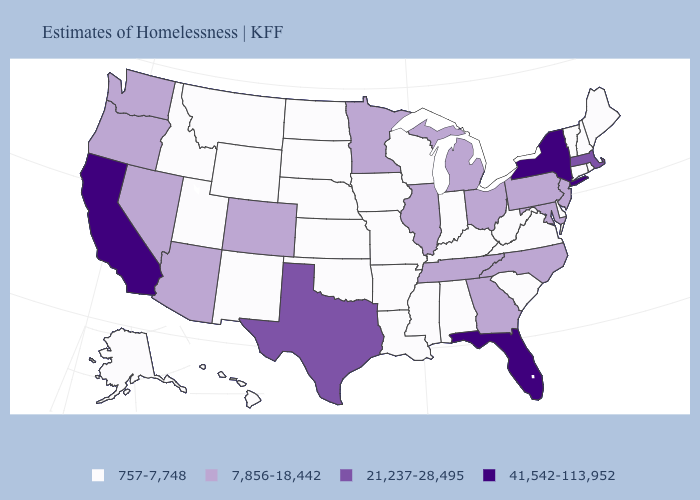Name the states that have a value in the range 7,856-18,442?
Keep it brief. Arizona, Colorado, Georgia, Illinois, Maryland, Michigan, Minnesota, Nevada, New Jersey, North Carolina, Ohio, Oregon, Pennsylvania, Tennessee, Washington. Among the states that border North Dakota , which have the highest value?
Write a very short answer. Minnesota. Name the states that have a value in the range 41,542-113,952?
Keep it brief. California, Florida, New York. Name the states that have a value in the range 757-7,748?
Be succinct. Alabama, Alaska, Arkansas, Connecticut, Delaware, Hawaii, Idaho, Indiana, Iowa, Kansas, Kentucky, Louisiana, Maine, Mississippi, Missouri, Montana, Nebraska, New Hampshire, New Mexico, North Dakota, Oklahoma, Rhode Island, South Carolina, South Dakota, Utah, Vermont, Virginia, West Virginia, Wisconsin, Wyoming. Name the states that have a value in the range 757-7,748?
Be succinct. Alabama, Alaska, Arkansas, Connecticut, Delaware, Hawaii, Idaho, Indiana, Iowa, Kansas, Kentucky, Louisiana, Maine, Mississippi, Missouri, Montana, Nebraska, New Hampshire, New Mexico, North Dakota, Oklahoma, Rhode Island, South Carolina, South Dakota, Utah, Vermont, Virginia, West Virginia, Wisconsin, Wyoming. Does the map have missing data?
Quick response, please. No. What is the lowest value in the South?
Be succinct. 757-7,748. Does New Jersey have the lowest value in the USA?
Keep it brief. No. Does Michigan have the lowest value in the USA?
Concise answer only. No. Among the states that border Rhode Island , which have the highest value?
Write a very short answer. Massachusetts. Does the first symbol in the legend represent the smallest category?
Short answer required. Yes. Among the states that border Oregon , does California have the lowest value?
Be succinct. No. What is the value of Kansas?
Write a very short answer. 757-7,748. Name the states that have a value in the range 21,237-28,495?
Be succinct. Massachusetts, Texas. 